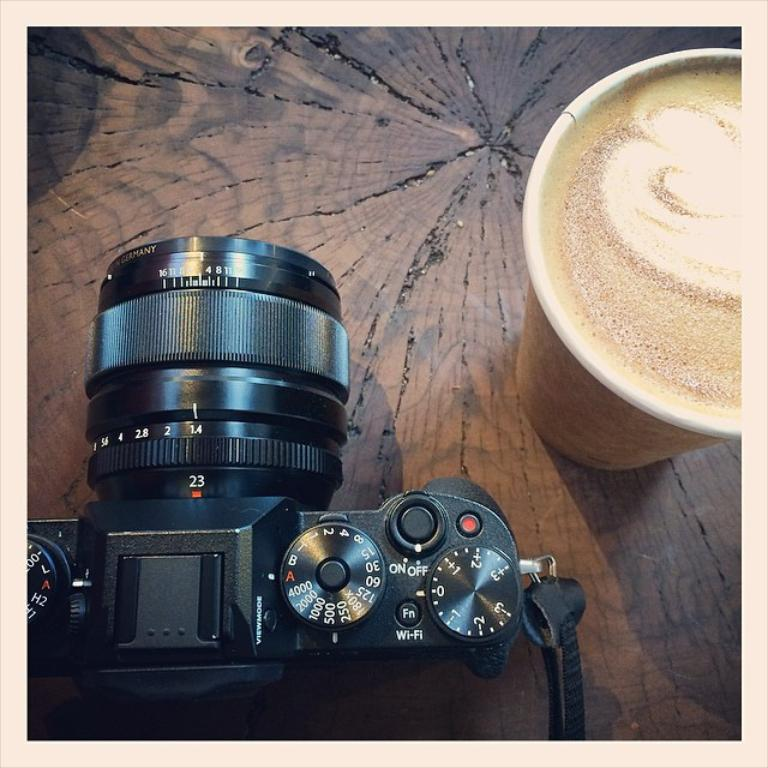What object is the main focus of the image? There is a camera in the image. Where is the camera positioned in the image? The camera is located at the left bottom of the image. What else can be seen in the image besides the camera? There is a coffee glass in the image. Where is the coffee glass placed? The coffee glass is on a table. Can you describe the setting of the image? The image is taken inside a room. What type of wine is being poured by the hand in the image? There is no wine or hand present in the image; it only features a camera and a coffee glass on a table inside a room. 